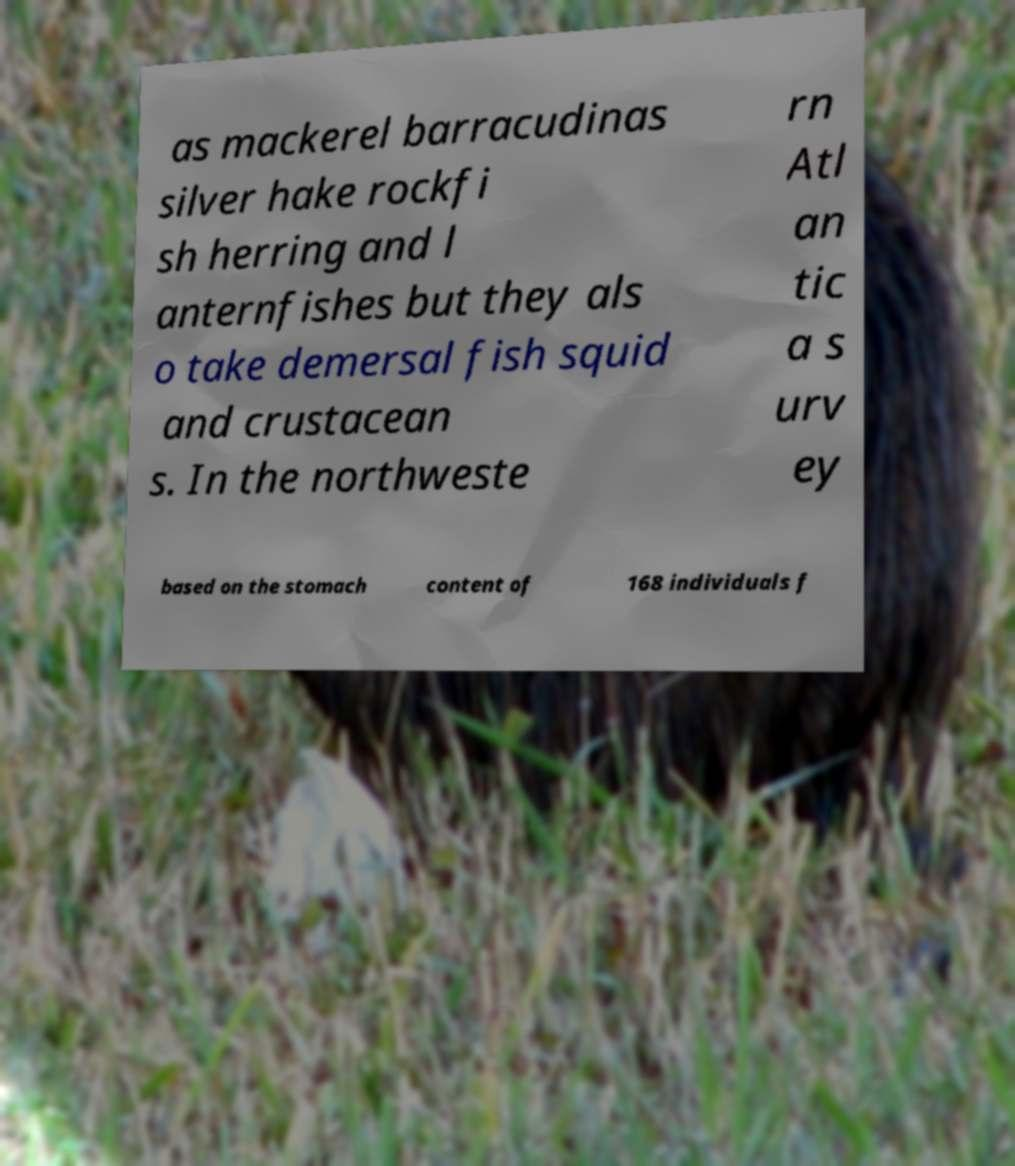For documentation purposes, I need the text within this image transcribed. Could you provide that? as mackerel barracudinas silver hake rockfi sh herring and l anternfishes but they als o take demersal fish squid and crustacean s. In the northweste rn Atl an tic a s urv ey based on the stomach content of 168 individuals f 